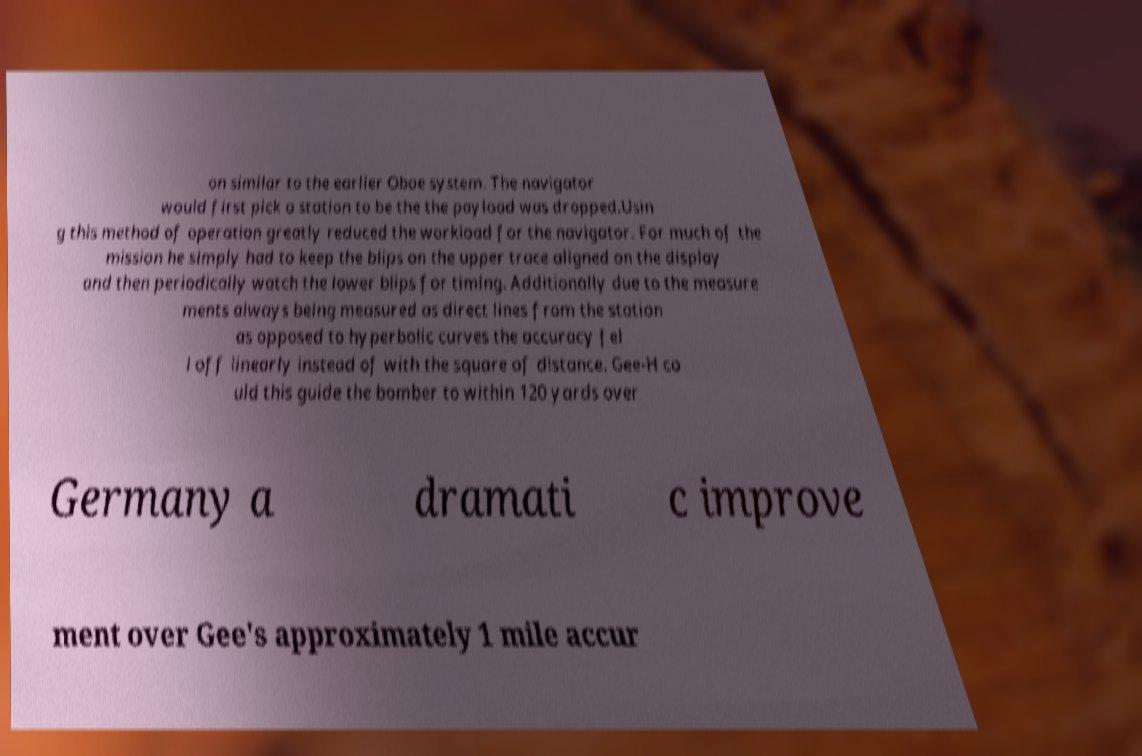Could you assist in decoding the text presented in this image and type it out clearly? on similar to the earlier Oboe system. The navigator would first pick a station to be the the payload was dropped.Usin g this method of operation greatly reduced the workload for the navigator. For much of the mission he simply had to keep the blips on the upper trace aligned on the display and then periodically watch the lower blips for timing. Additionally due to the measure ments always being measured as direct lines from the station as opposed to hyperbolic curves the accuracy fel l off linearly instead of with the square of distance. Gee-H co uld this guide the bomber to within 120 yards over Germany a dramati c improve ment over Gee's approximately 1 mile accur 